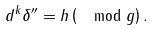Convert formula to latex. <formula><loc_0><loc_0><loc_500><loc_500>d ^ { k } \delta ^ { \prime \prime } = h \left ( \mod g \right ) .</formula> 